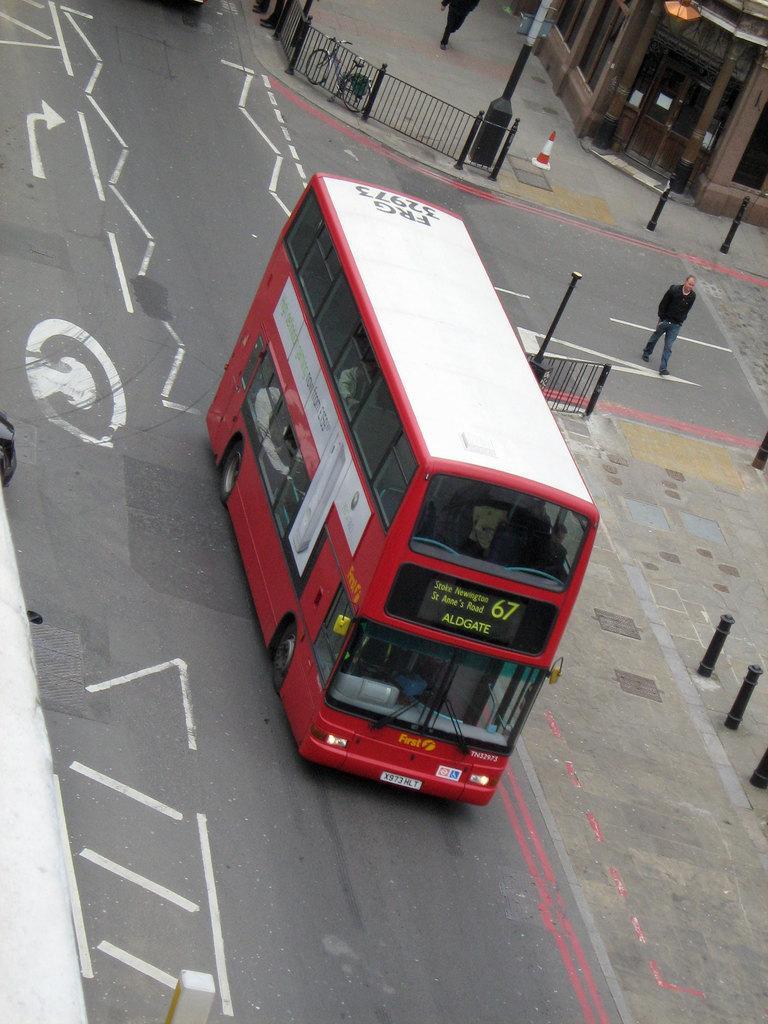Could you give a brief overview of what you see in this image? In the middle I can see a bus on the road. In the background I can see a fence, poles, buildings and two persons. This image is taken during a day. 